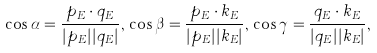<formula> <loc_0><loc_0><loc_500><loc_500>\cos \alpha = \frac { p _ { E } \cdot q _ { E } } { | p _ { E } | | q _ { E } | } , \, \cos \beta = \frac { p _ { E } \cdot k _ { E } } { | p _ { E } | | k _ { E } | } , \, \cos \gamma = \frac { q _ { E } \cdot k _ { E } } { | q _ { E } | | k _ { E } | } ,</formula> 